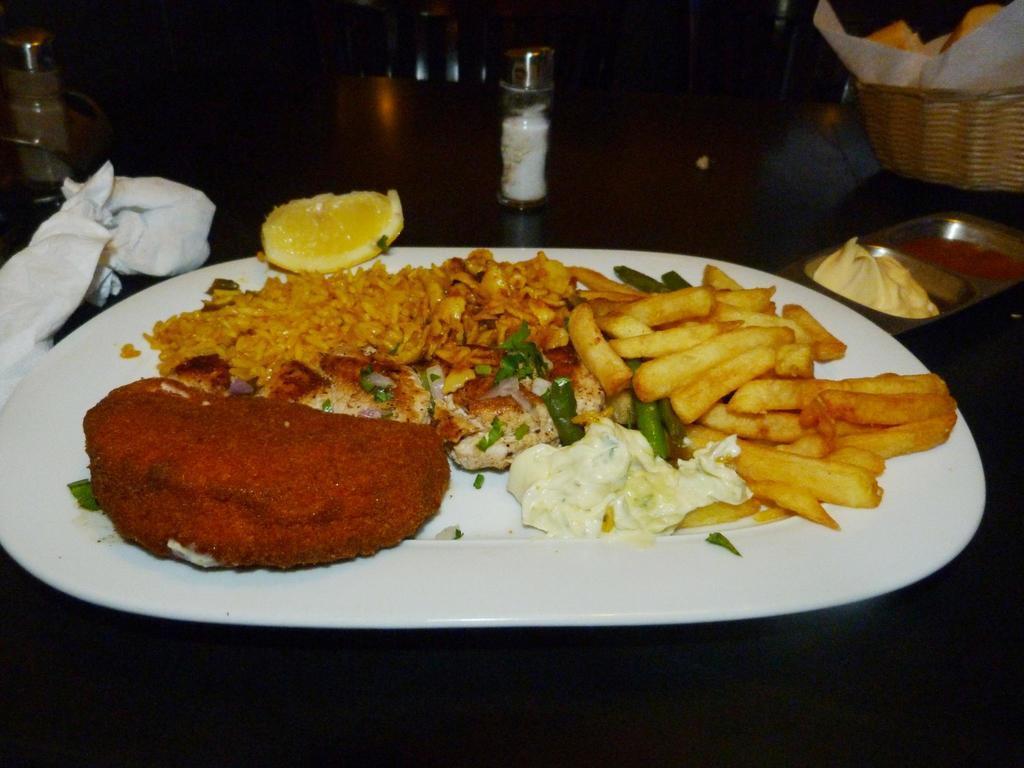How would you summarize this image in a sentence or two? In the image we can see a plate, white in color. On the plate we can see there are different food items, there is even a slice of lemon. This is a salt container and a wooden basket. 